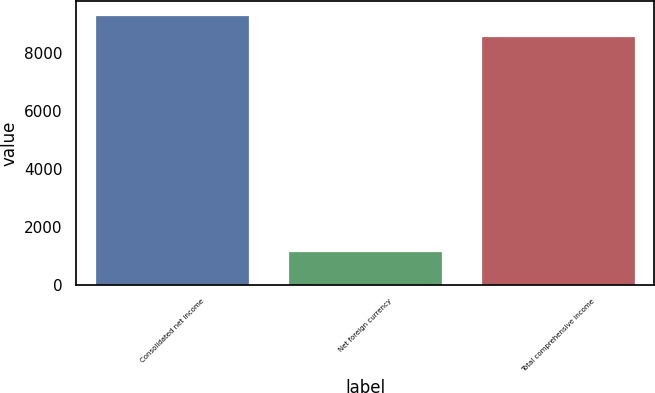<chart> <loc_0><loc_0><loc_500><loc_500><bar_chart><fcel>Consolidated net income<fcel>Net foreign currency<fcel>Total comprehensive income<nl><fcel>9319.9<fcel>1187<fcel>8576<nl></chart> 